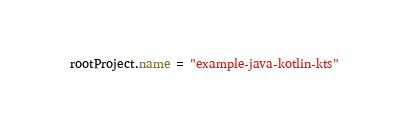<code> <loc_0><loc_0><loc_500><loc_500><_Kotlin_>rootProject.name = "example-java-kotlin-kts"

</code> 